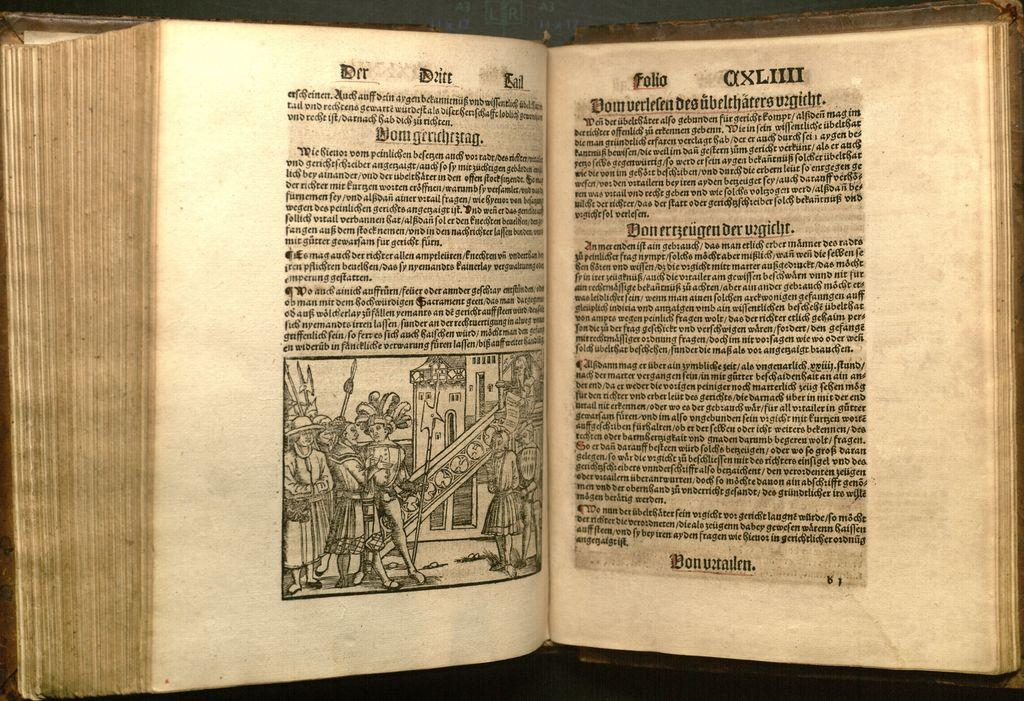<image>
Render a clear and concise summary of the photo. An ancient German book has a paragraph titled Domgrrichezrag 